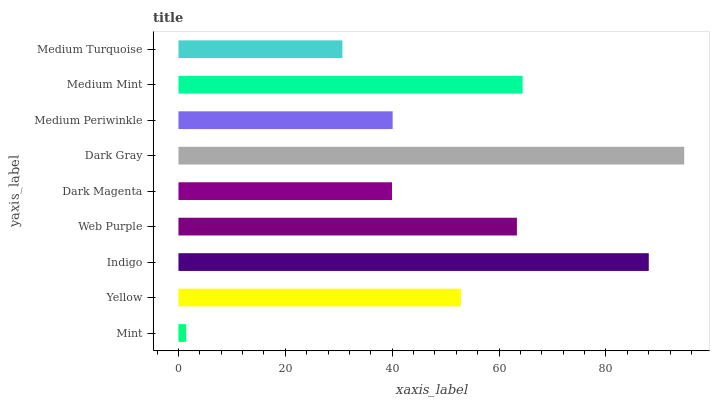Is Mint the minimum?
Answer yes or no. Yes. Is Dark Gray the maximum?
Answer yes or no. Yes. Is Yellow the minimum?
Answer yes or no. No. Is Yellow the maximum?
Answer yes or no. No. Is Yellow greater than Mint?
Answer yes or no. Yes. Is Mint less than Yellow?
Answer yes or no. Yes. Is Mint greater than Yellow?
Answer yes or no. No. Is Yellow less than Mint?
Answer yes or no. No. Is Yellow the high median?
Answer yes or no. Yes. Is Yellow the low median?
Answer yes or no. Yes. Is Dark Gray the high median?
Answer yes or no. No. Is Medium Mint the low median?
Answer yes or no. No. 